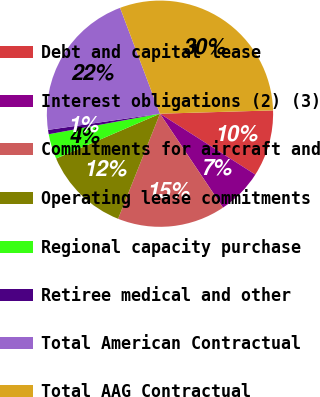Convert chart. <chart><loc_0><loc_0><loc_500><loc_500><pie_chart><fcel>Debt and capital lease<fcel>Interest obligations (2) (3)<fcel>Commitments for aircraft and<fcel>Operating lease commitments<fcel>Regional capacity purchase<fcel>Retiree medical and other<fcel>Total American Contractual<fcel>Total AAG Contractual<nl><fcel>9.51%<fcel>6.55%<fcel>15.44%<fcel>12.48%<fcel>3.58%<fcel>0.62%<fcel>21.55%<fcel>30.27%<nl></chart> 